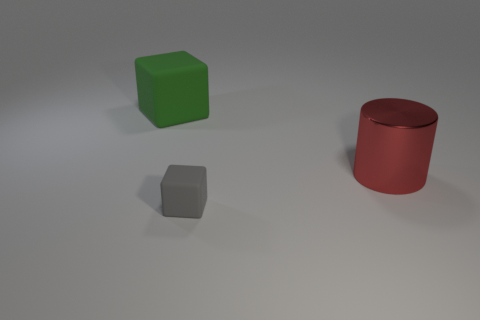There is another gray object that is the same shape as the large matte object; what size is it?
Provide a short and direct response. Small. There is a rubber thing that is on the left side of the tiny gray cube; what shape is it?
Provide a succinct answer. Cube. Is the number of cylinders less than the number of big green metal cylinders?
Provide a short and direct response. No. Is the large object on the right side of the large matte block made of the same material as the green cube?
Offer a terse response. No. Is there any other thing that is the same size as the gray matte cube?
Make the answer very short. No. Are there any big red cylinders behind the big green thing?
Offer a very short reply. No. What color is the big metal object that is on the right side of the matte thing that is on the right side of the object that is behind the shiny cylinder?
Ensure brevity in your answer.  Red. What shape is the red metal object that is the same size as the green block?
Provide a succinct answer. Cylinder. Is the number of small yellow objects greater than the number of big green rubber objects?
Your answer should be compact. No. There is a matte thing on the right side of the big green thing; is there a red thing that is in front of it?
Provide a succinct answer. No. 